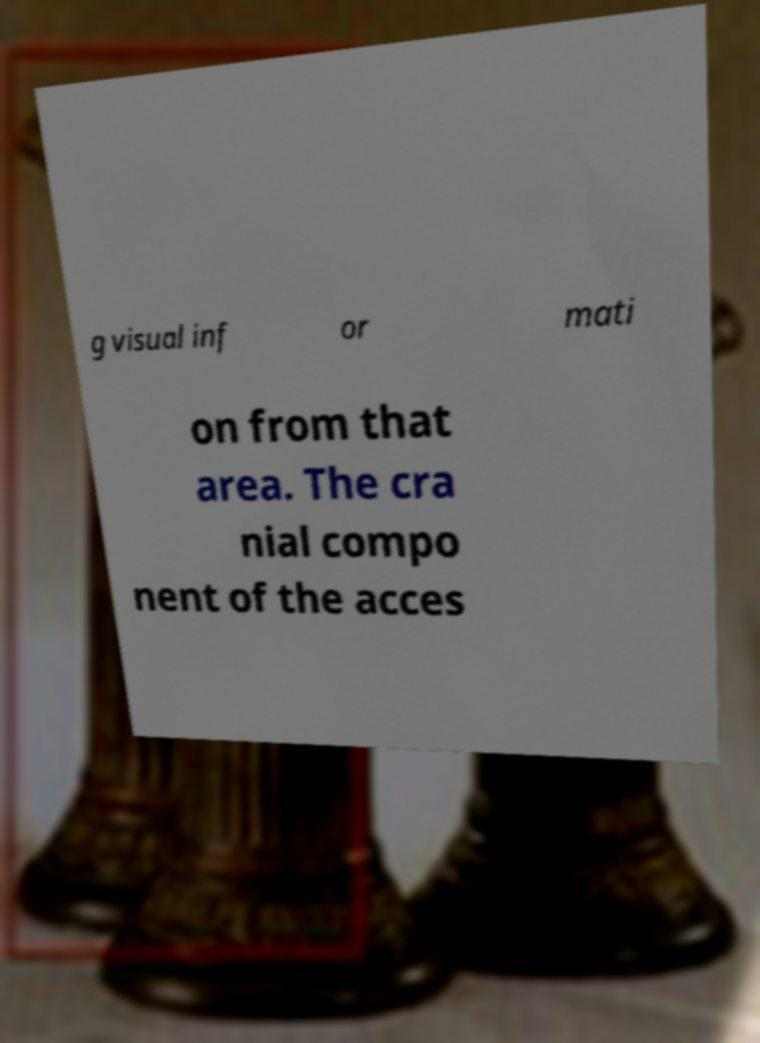Can you read and provide the text displayed in the image?This photo seems to have some interesting text. Can you extract and type it out for me? g visual inf or mati on from that area. The cra nial compo nent of the acces 